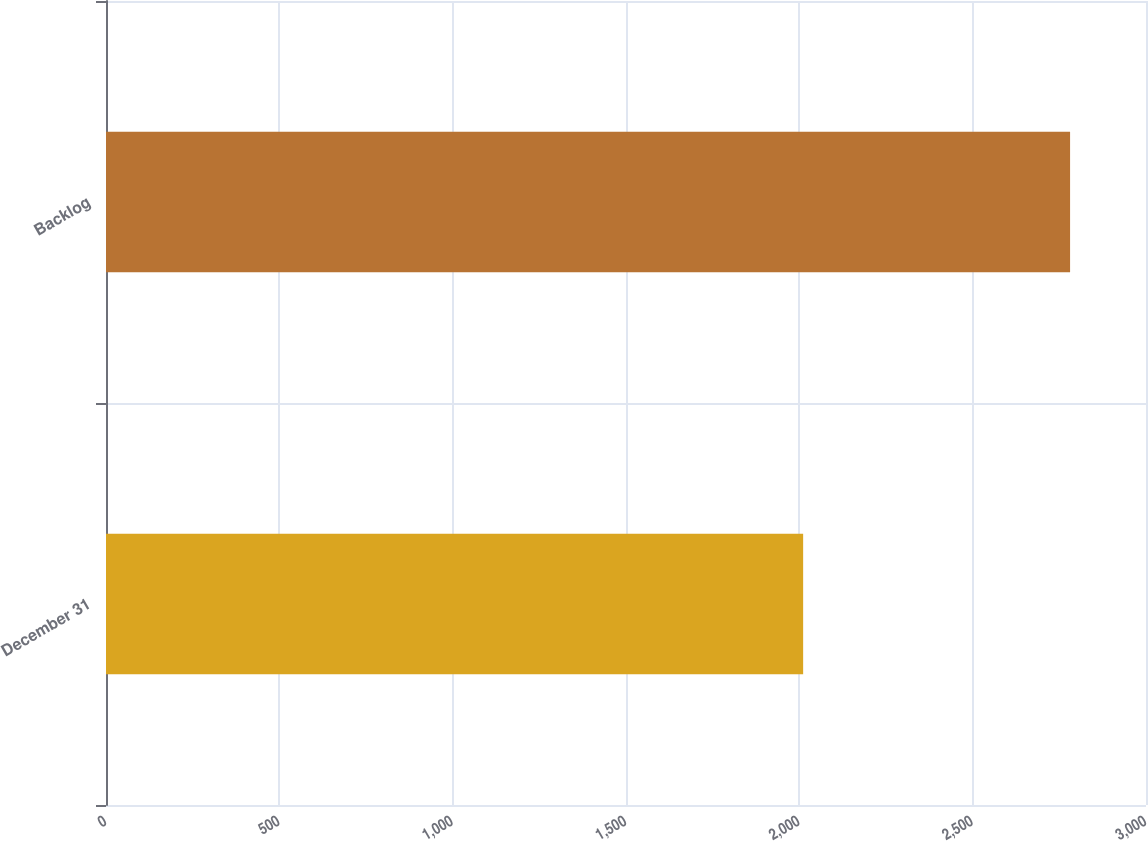Convert chart to OTSL. <chart><loc_0><loc_0><loc_500><loc_500><bar_chart><fcel>December 31<fcel>Backlog<nl><fcel>2011<fcel>2781<nl></chart> 